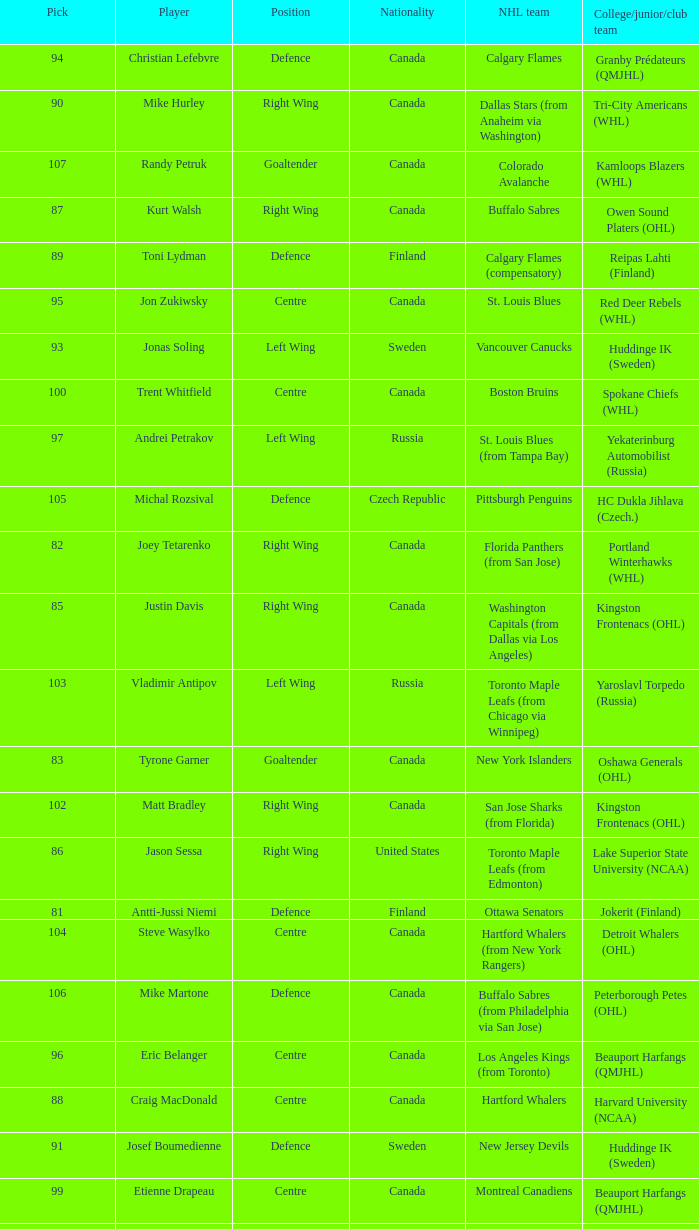What position does that draft pick play from Lake Superior State University (NCAA)? Right Wing. 